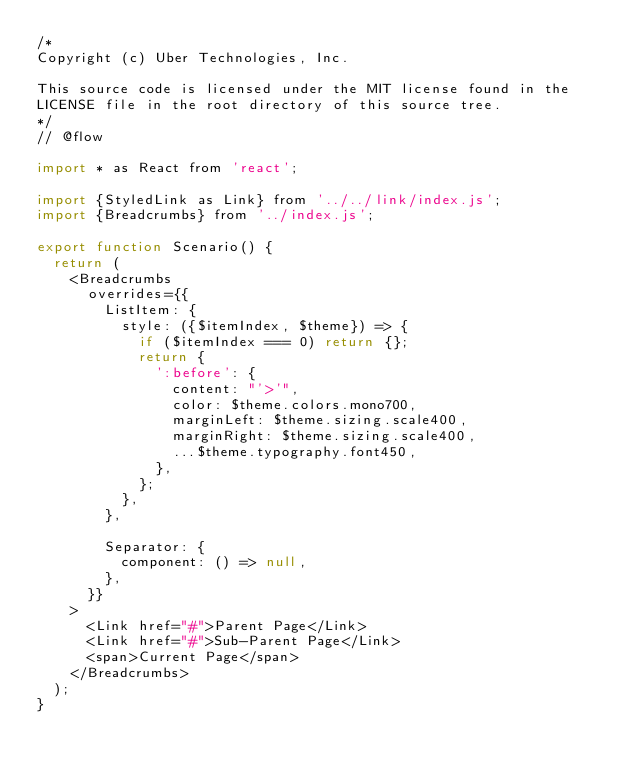Convert code to text. <code><loc_0><loc_0><loc_500><loc_500><_JavaScript_>/*
Copyright (c) Uber Technologies, Inc.

This source code is licensed under the MIT license found in the
LICENSE file in the root directory of this source tree.
*/
// @flow

import * as React from 'react';

import {StyledLink as Link} from '../../link/index.js';
import {Breadcrumbs} from '../index.js';

export function Scenario() {
  return (
    <Breadcrumbs
      overrides={{
        ListItem: {
          style: ({$itemIndex, $theme}) => {
            if ($itemIndex === 0) return {};
            return {
              ':before': {
                content: "'>'",
                color: $theme.colors.mono700,
                marginLeft: $theme.sizing.scale400,
                marginRight: $theme.sizing.scale400,
                ...$theme.typography.font450,
              },
            };
          },
        },

        Separator: {
          component: () => null,
        },
      }}
    >
      <Link href="#">Parent Page</Link>
      <Link href="#">Sub-Parent Page</Link>
      <span>Current Page</span>
    </Breadcrumbs>
  );
}
</code> 